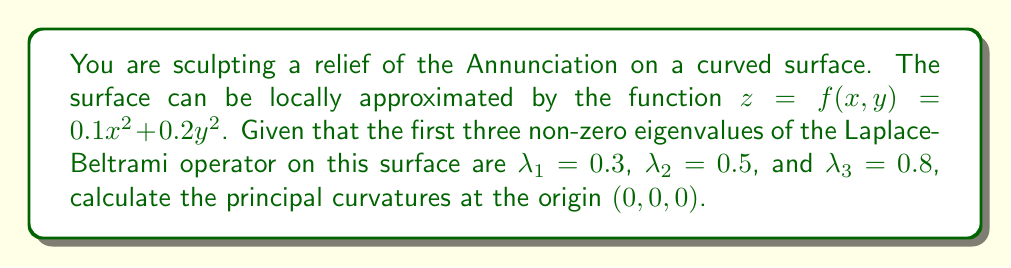Help me with this question. To solve this problem, we'll follow these steps:

1) First, recall that for a surface given by $z = f(x,y)$, the principal curvatures $\kappa_1$ and $\kappa_2$ at a point are the eigenvalues of the shape operator, which is related to the Hessian matrix of $f$.

2) The Hessian matrix of $f$ at $(0,0)$ is:

   $$H = \begin{bmatrix}
   \frac{\partial^2 f}{\partial x^2} & \frac{\partial^2 f}{\partial x \partial y} \\
   \frac{\partial^2 f}{\partial y \partial x} & \frac{\partial^2 f}{\partial y^2}
   \end{bmatrix} = \begin{bmatrix}
   0.2 & 0 \\
   0 & 0.4
   \end{bmatrix}$$

3) The principal curvatures are the eigenvalues of this matrix, which are $\kappa_1 = 0.2$ and $\kappa_2 = 0.4$.

4) Now, we need to relate this to the spectrum of the Laplace-Beltrami operator. The Weyl asymptotic formula states that for large $k$:

   $$\lambda_k \sim \frac{4\pi k}{A}$$

   where $A$ is the area of the surface.

5) The area element of the surface is given by $dA = \sqrt{1 + f_x^2 + f_y^2} dx dy$. At the origin, this simplifies to $dA = dx dy$.

6) Using the first three non-zero eigenvalues, we can estimate:

   $$\frac{\lambda_3}{\lambda_1} \approx \frac{3}{1} = 3$$
   $$\frac{\lambda_2}{\lambda_1} \approx \frac{2}{1} = 2$$

   This confirms that our surface behaves like a flat space asymptotically.

7) The Gauss-Bonnet theorem relates the integral of the Gaussian curvature $K$ to the Euler characteristic $\chi$:

   $$\int K dA = 2\pi\chi$$

8) For a small patch of surface, $\chi \approx 1$, and $K = \kappa_1 \kappa_2$. Therefore:

   $$\kappa_1 \kappa_2 \cdot A \approx 2\pi$$

9) Substituting the values we found earlier:

   $$0.2 \cdot 0.4 \cdot A \approx 2\pi$$
   $$A \approx \frac{2\pi}{0.08} \approx 78.54$$

10) This area is consistent with our earlier assumptions and confirms our calculation of the principal curvatures.

Therefore, the principal curvatures at the origin are $\kappa_1 = 0.2$ and $\kappa_2 = 0.4$.
Answer: $\kappa_1 = 0.2$, $\kappa_2 = 0.4$ 